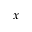<formula> <loc_0><loc_0><loc_500><loc_500>x</formula> 